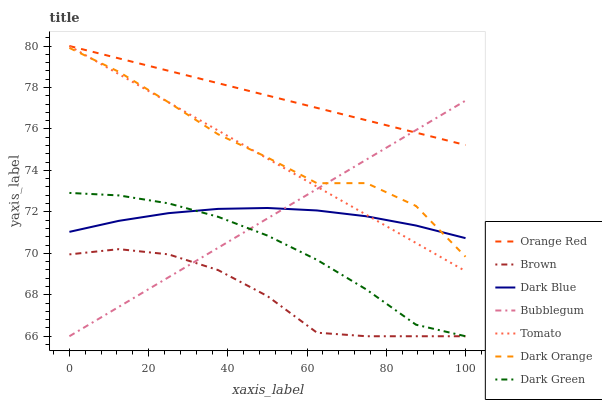Does Brown have the minimum area under the curve?
Answer yes or no. Yes. Does Orange Red have the maximum area under the curve?
Answer yes or no. Yes. Does Dark Orange have the minimum area under the curve?
Answer yes or no. No. Does Dark Orange have the maximum area under the curve?
Answer yes or no. No. Is Bubblegum the smoothest?
Answer yes or no. Yes. Is Dark Orange the roughest?
Answer yes or no. Yes. Is Brown the smoothest?
Answer yes or no. No. Is Brown the roughest?
Answer yes or no. No. Does Brown have the lowest value?
Answer yes or no. Yes. Does Dark Orange have the lowest value?
Answer yes or no. No. Does Orange Red have the highest value?
Answer yes or no. Yes. Does Dark Orange have the highest value?
Answer yes or no. No. Is Dark Orange less than Orange Red?
Answer yes or no. Yes. Is Tomato greater than Brown?
Answer yes or no. Yes. Does Dark Blue intersect Dark Orange?
Answer yes or no. Yes. Is Dark Blue less than Dark Orange?
Answer yes or no. No. Is Dark Blue greater than Dark Orange?
Answer yes or no. No. Does Dark Orange intersect Orange Red?
Answer yes or no. No. 